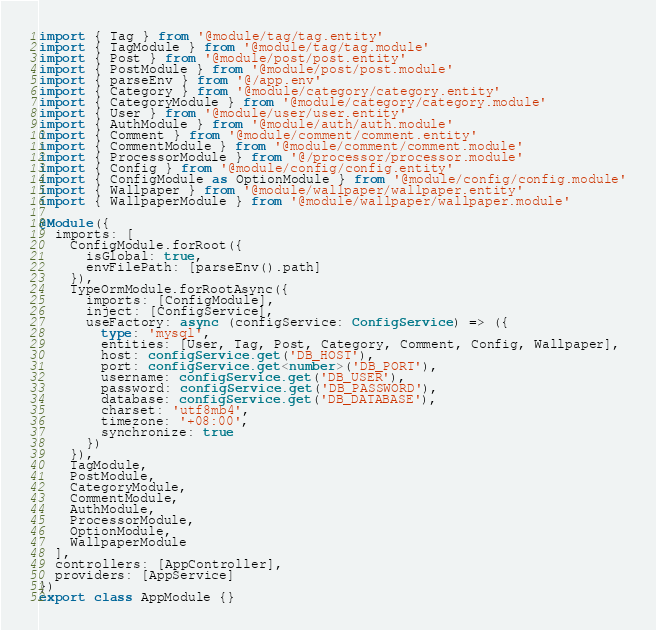<code> <loc_0><loc_0><loc_500><loc_500><_TypeScript_>import { Tag } from '@module/tag/tag.entity'
import { TagModule } from '@module/tag/tag.module'
import { Post } from '@module/post/post.entity'
import { PostModule } from '@module/post/post.module'
import { parseEnv } from '@/app.env'
import { Category } from '@module/category/category.entity'
import { CategoryModule } from '@module/category/category.module'
import { User } from '@module/user/user.entity'
import { AuthModule } from '@module/auth/auth.module'
import { Comment } from '@module/comment/comment.entity'
import { CommentModule } from '@module/comment/comment.module'
import { ProcessorModule } from '@/processor/processor.module'
import { Config } from '@module/config/config.entity'
import { ConfigModule as OptionModule } from '@module/config/config.module'
import { Wallpaper } from '@module/wallpaper/wallpaper.entity'
import { WallpaperModule } from '@module/wallpaper/wallpaper.module'

@Module({
  imports: [
    ConfigModule.forRoot({
      isGlobal: true,
      envFilePath: [parseEnv().path]
    }),
    TypeOrmModule.forRootAsync({
      imports: [ConfigModule],
      inject: [ConfigService],
      useFactory: async (configService: ConfigService) => ({
        type: 'mysql',
        entities: [User, Tag, Post, Category, Comment, Config, Wallpaper],
        host: configService.get('DB_HOST'),
        port: configService.get<number>('DB_PORT'),
        username: configService.get('DB_USER'),
        password: configService.get('DB_PASSWORD'),
        database: configService.get('DB_DATABASE'),
        charset: 'utf8mb4',
        timezone: '+08:00',
        synchronize: true
      })
    }),
    TagModule,
    PostModule,
    CategoryModule,
    CommentModule,
    AuthModule,
    ProcessorModule,
    OptionModule,
    WallpaperModule
  ],
  controllers: [AppController],
  providers: [AppService]
})
export class AppModule {}
</code> 